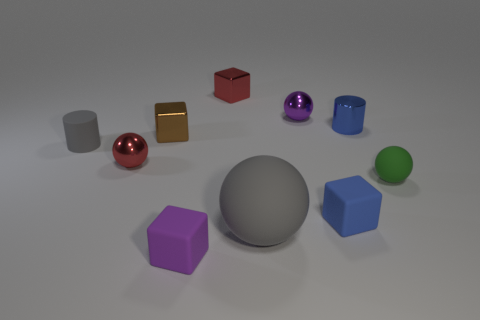Are there any brown shiny blocks right of the gray rubber ball? After carefully examining the image, I can confirm that there are no brown shiny blocks located to the right of the gray rubber ball. 